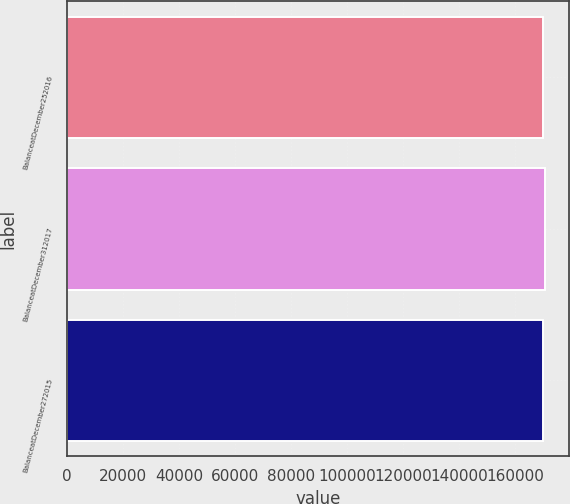Convert chart. <chart><loc_0><loc_0><loc_500><loc_500><bar_chart><fcel>BalanceatDecember252016<fcel>BalanceatDecember312017<fcel>BalanceatDecember272015<nl><fcel>169833<fcel>170699<fcel>170110<nl></chart> 